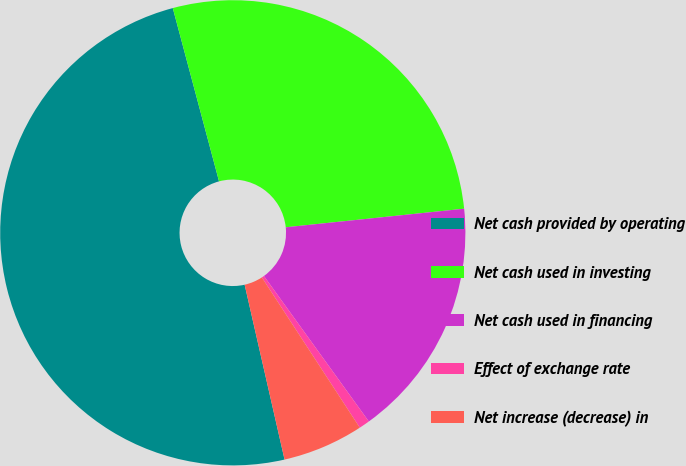<chart> <loc_0><loc_0><loc_500><loc_500><pie_chart><fcel>Net cash provided by operating<fcel>Net cash used in investing<fcel>Net cash used in financing<fcel>Effect of exchange rate<fcel>Net increase (decrease) in<nl><fcel>49.42%<fcel>27.5%<fcel>16.71%<fcel>0.75%<fcel>5.62%<nl></chart> 